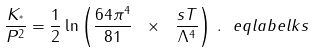Convert formula to latex. <formula><loc_0><loc_0><loc_500><loc_500>\frac { K _ { ^ { * } } } { P ^ { 2 } } = \frac { 1 } { 2 } \ln \left ( \frac { 6 4 \pi ^ { 4 } } { 8 1 } \ \times \ \frac { s T } { \Lambda ^ { 4 } } \right ) \, . \ e q l a b e l { k s }</formula> 